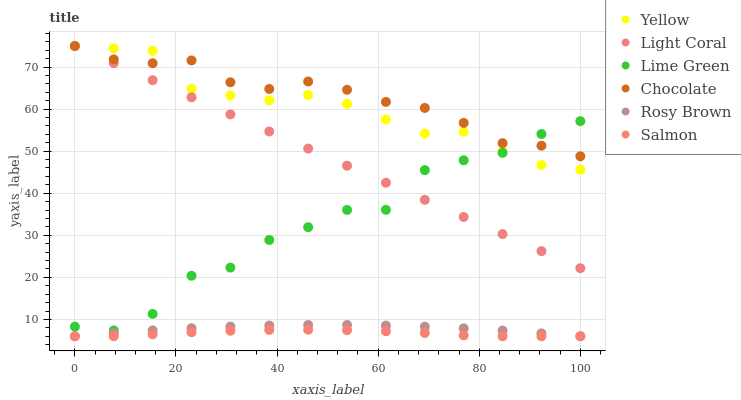Does Salmon have the minimum area under the curve?
Answer yes or no. Yes. Does Chocolate have the maximum area under the curve?
Answer yes or no. Yes. Does Yellow have the minimum area under the curve?
Answer yes or no. No. Does Yellow have the maximum area under the curve?
Answer yes or no. No. Is Light Coral the smoothest?
Answer yes or no. Yes. Is Lime Green the roughest?
Answer yes or no. Yes. Is Salmon the smoothest?
Answer yes or no. No. Is Salmon the roughest?
Answer yes or no. No. Does Rosy Brown have the lowest value?
Answer yes or no. Yes. Does Yellow have the lowest value?
Answer yes or no. No. Does Light Coral have the highest value?
Answer yes or no. Yes. Does Salmon have the highest value?
Answer yes or no. No. Is Rosy Brown less than Yellow?
Answer yes or no. Yes. Is Yellow greater than Rosy Brown?
Answer yes or no. Yes. Does Chocolate intersect Light Coral?
Answer yes or no. Yes. Is Chocolate less than Light Coral?
Answer yes or no. No. Is Chocolate greater than Light Coral?
Answer yes or no. No. Does Rosy Brown intersect Yellow?
Answer yes or no. No. 